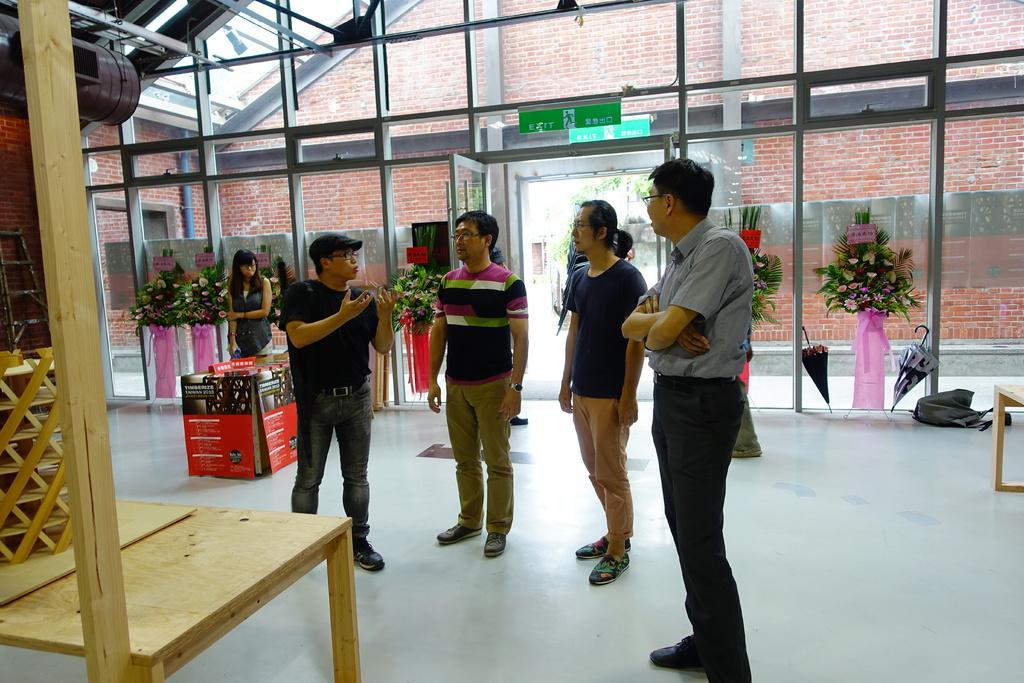In one or two sentences, can you explain what this image depicts? In this image there are four people standing and talking with each other, around them there are some objects, behind them there is a door entrance, near the door there is a glass wall, on the other side of the glass wall there is a brick wall, behind the person there is a woman standing. 